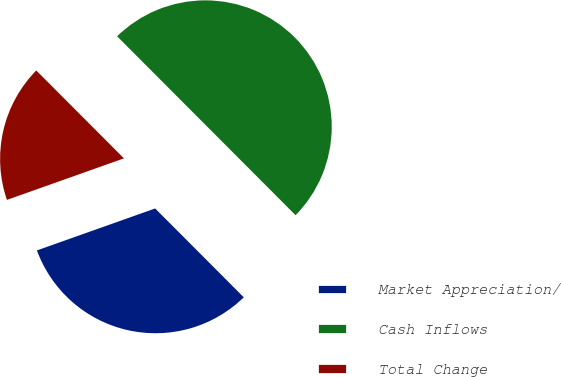Convert chart. <chart><loc_0><loc_0><loc_500><loc_500><pie_chart><fcel>Market Appreciation/<fcel>Cash Inflows<fcel>Total Change<nl><fcel>32.05%<fcel>50.0%<fcel>17.95%<nl></chart> 